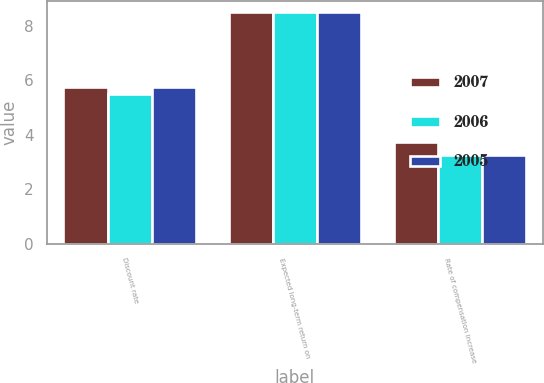Convert chart to OTSL. <chart><loc_0><loc_0><loc_500><loc_500><stacked_bar_chart><ecel><fcel>Discount rate<fcel>Expected long-term return on<fcel>Rate of compensation increase<nl><fcel>2007<fcel>5.75<fcel>8.5<fcel>3.75<nl><fcel>2006<fcel>5.5<fcel>8.5<fcel>3.25<nl><fcel>2005<fcel>5.75<fcel>8.5<fcel>3.25<nl></chart> 